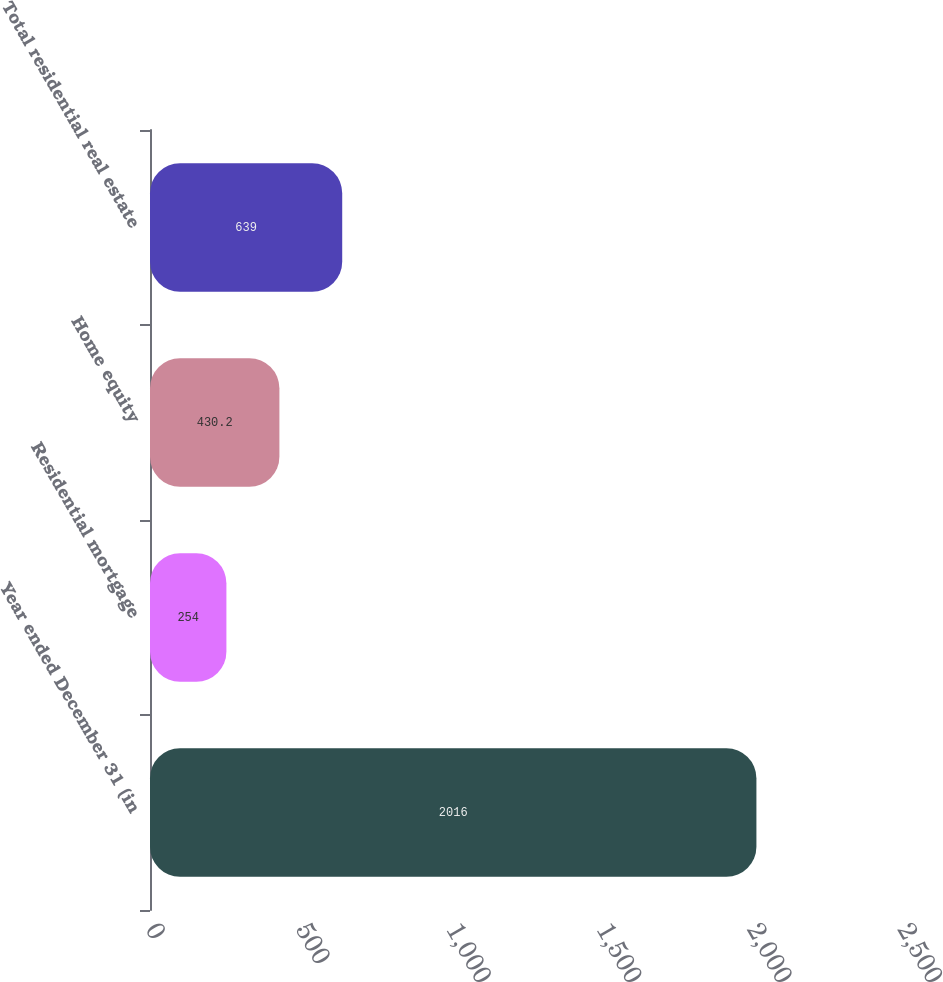Convert chart to OTSL. <chart><loc_0><loc_0><loc_500><loc_500><bar_chart><fcel>Year ended December 31 (in<fcel>Residential mortgage<fcel>Home equity<fcel>Total residential real estate<nl><fcel>2016<fcel>254<fcel>430.2<fcel>639<nl></chart> 